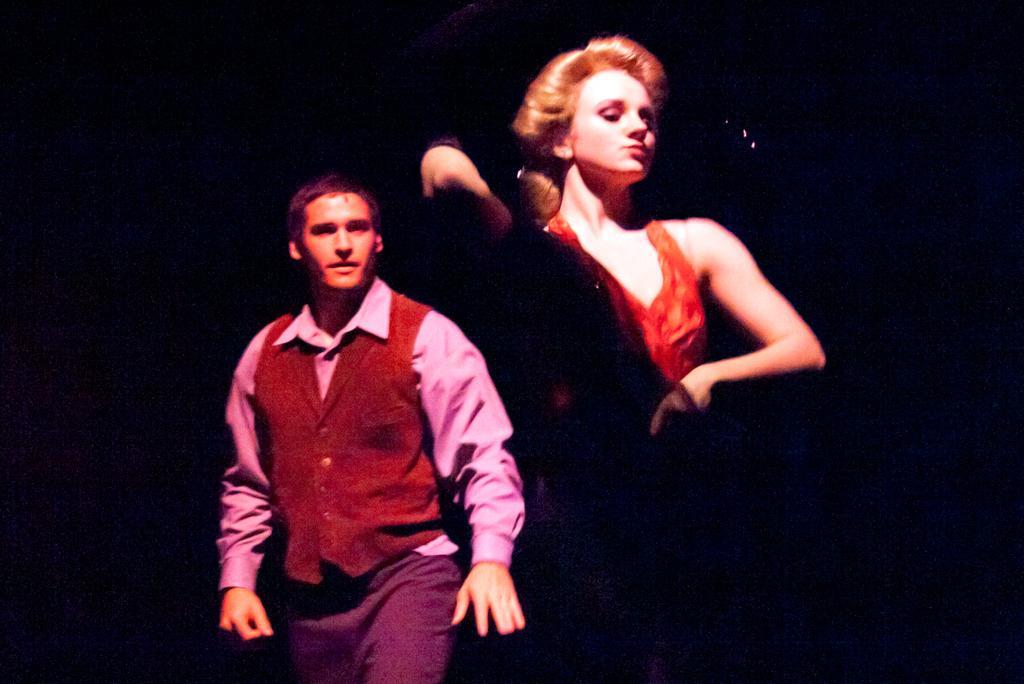How would you summarize this image in a sentence or two? In this image I can see two people with the different color dresses. And there is a black background. 